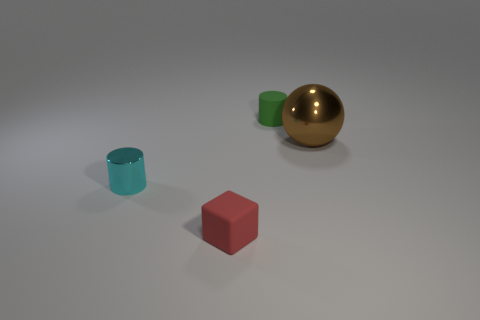There is a thing in front of the tiny cyan cylinder; does it have the same shape as the metallic object that is left of the green thing? no 